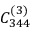Convert formula to latex. <formula><loc_0><loc_0><loc_500><loc_500>C _ { 3 4 4 } ^ { ( 3 ) }</formula> 